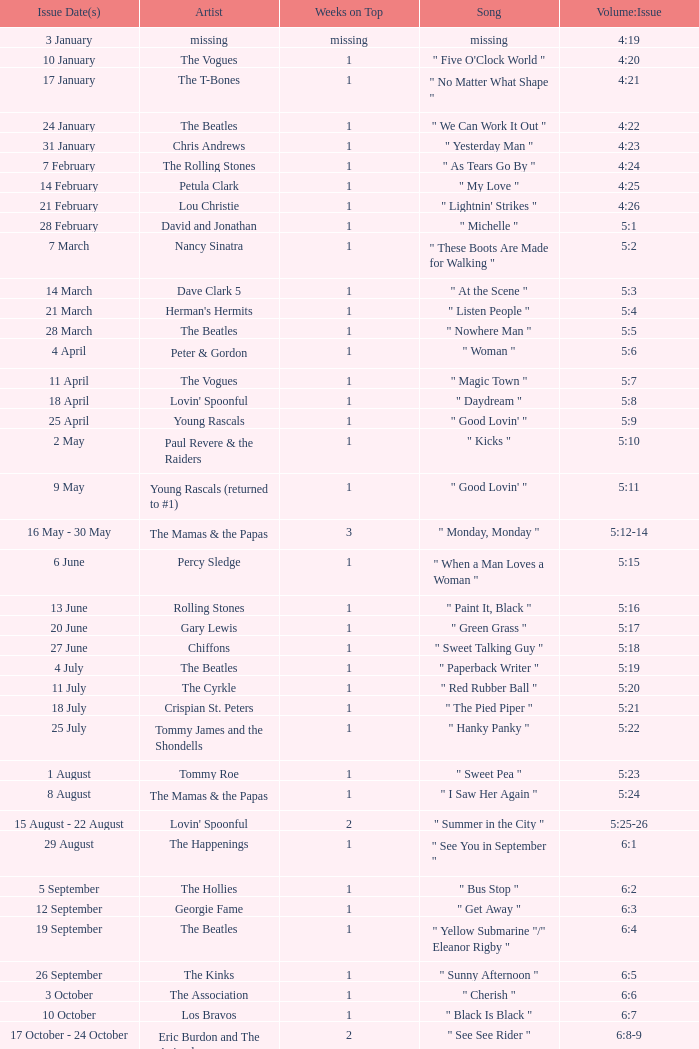With an issue date(s) of 12 September, what is in the column for Weeks on Top? 1.0. 